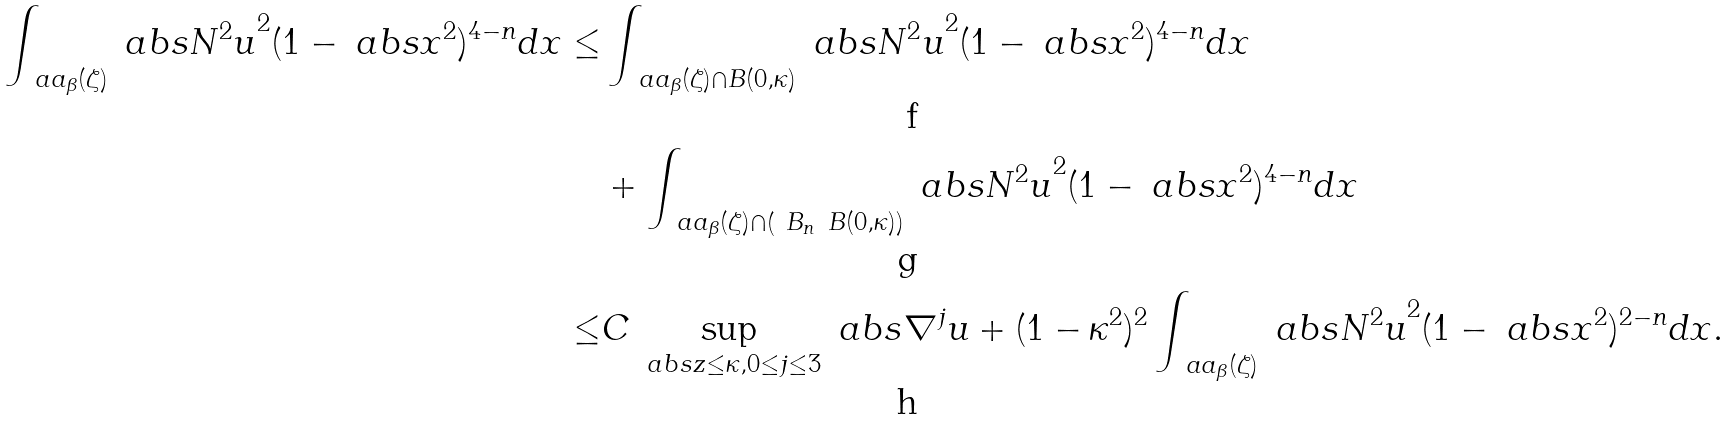Convert formula to latex. <formula><loc_0><loc_0><loc_500><loc_500>\int _ { \ a a _ { \beta } ( \zeta ) } \ a b s { N ^ { 2 } u } ^ { 2 } ( 1 - \ a b s { x } ^ { 2 } ) ^ { 4 - n } d x \leq & \int _ { \ a a _ { \beta } ( \zeta ) \cap B ( 0 , \kappa ) } \ a b s { N ^ { 2 } u } ^ { 2 } ( 1 - \ a b s { x } ^ { 2 } ) ^ { 4 - n } d x \\ & + \int _ { \ a a _ { \beta } ( \zeta ) \cap \left ( \ B _ { n } \ B ( 0 , \kappa ) \right ) } \ a b s { N ^ { 2 } u } ^ { 2 } ( 1 - \ a b s { x } ^ { 2 } ) ^ { 4 - n } d x \\ \leq & C \sup _ { \ a b s { z } \leq \kappa , 0 \leq j \leq 3 } \ a b s { \nabla ^ { j } u } + ( 1 - \kappa ^ { 2 } ) ^ { 2 } \int _ { \ a a _ { \beta } ( \zeta ) } \ a b s { N ^ { 2 } u } ^ { 2 } ( 1 - \ a b s { x } ^ { 2 } ) ^ { 2 - n } d x .</formula> 